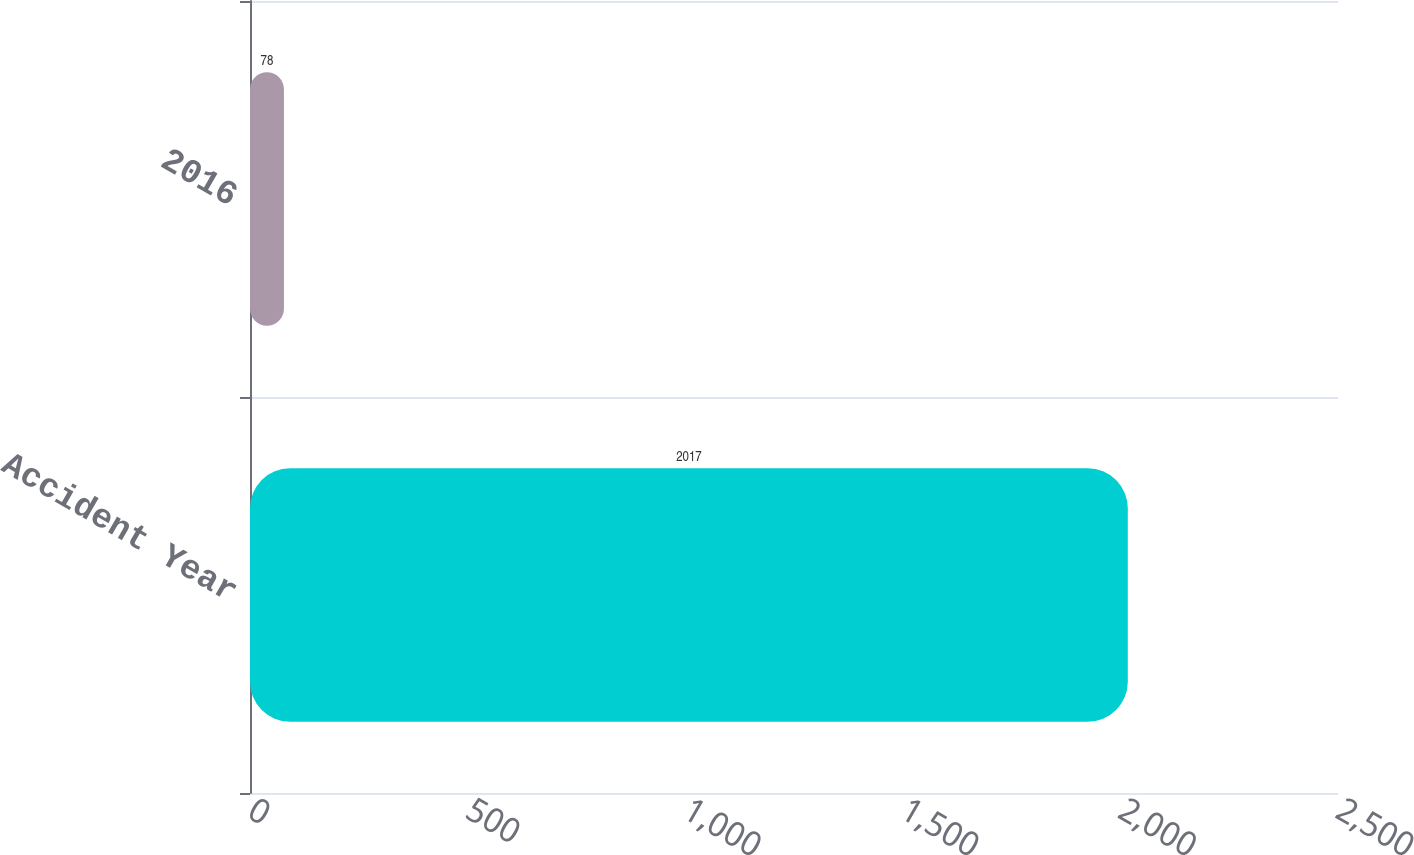Convert chart to OTSL. <chart><loc_0><loc_0><loc_500><loc_500><bar_chart><fcel>Accident Year<fcel>2016<nl><fcel>2017<fcel>78<nl></chart> 